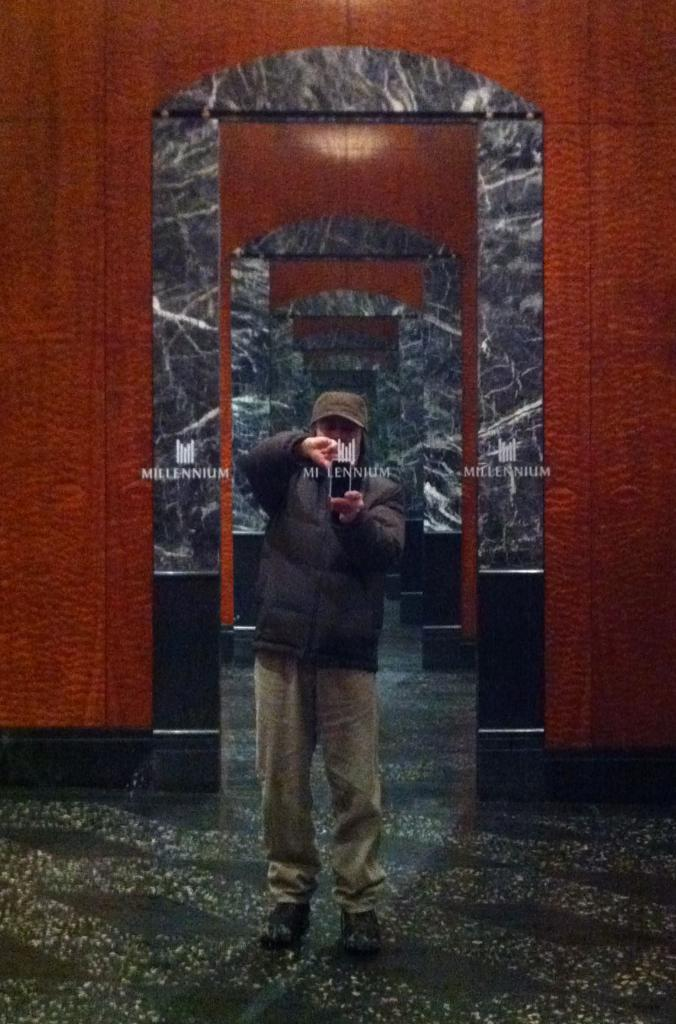What is the main subject of the image? There is a man in the image. What is the man doing in the image? The man is standing in the image. What type of clothing is the man wearing on his head? The man is wearing a cap in the image. How many crows are sitting on the man's shoulder in the image? There are no crows present in the image. What does the man desire in the image? The image does not provide information about the man's desires. 